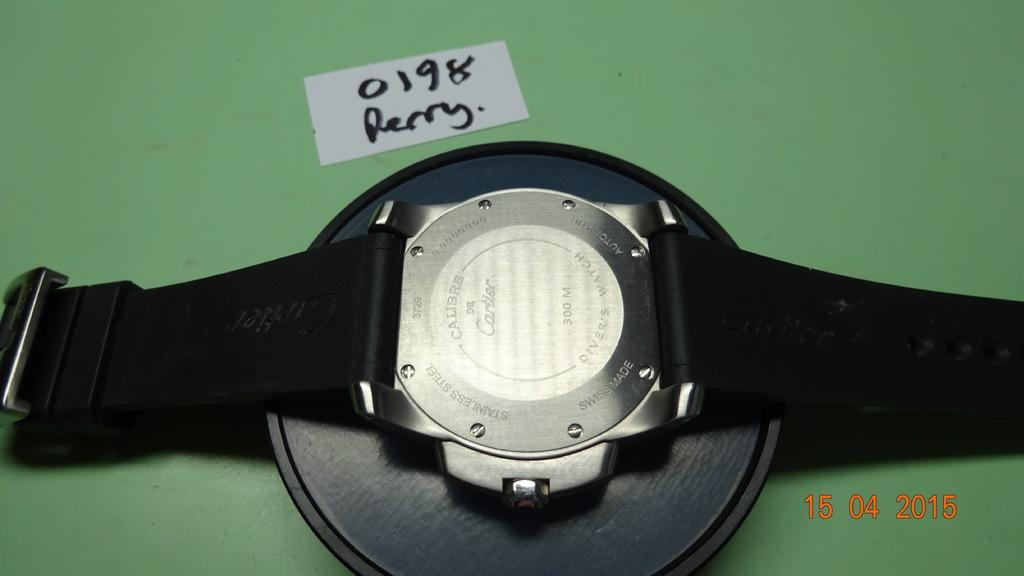<image>
Render a clear and concise summary of the photo. Wristwatch with a white piece of paper that says 0198 Perry. 